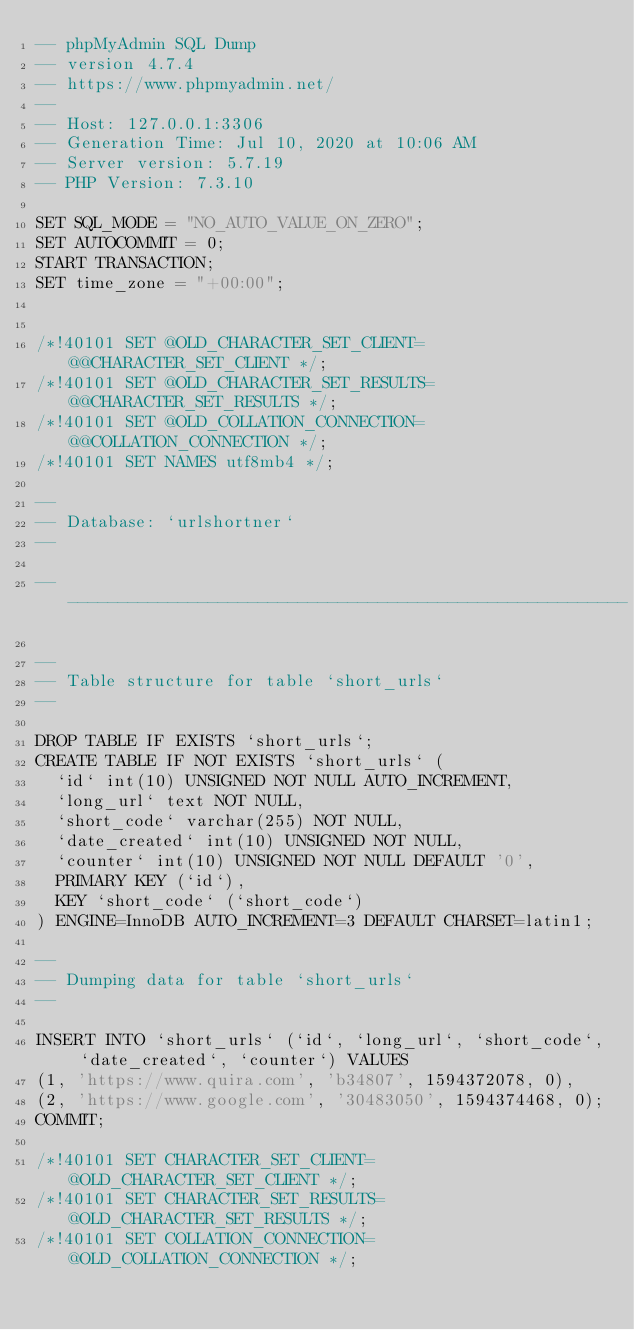<code> <loc_0><loc_0><loc_500><loc_500><_SQL_>-- phpMyAdmin SQL Dump
-- version 4.7.4
-- https://www.phpmyadmin.net/
--
-- Host: 127.0.0.1:3306
-- Generation Time: Jul 10, 2020 at 10:06 AM
-- Server version: 5.7.19
-- PHP Version: 7.3.10

SET SQL_MODE = "NO_AUTO_VALUE_ON_ZERO";
SET AUTOCOMMIT = 0;
START TRANSACTION;
SET time_zone = "+00:00";


/*!40101 SET @OLD_CHARACTER_SET_CLIENT=@@CHARACTER_SET_CLIENT */;
/*!40101 SET @OLD_CHARACTER_SET_RESULTS=@@CHARACTER_SET_RESULTS */;
/*!40101 SET @OLD_COLLATION_CONNECTION=@@COLLATION_CONNECTION */;
/*!40101 SET NAMES utf8mb4 */;

--
-- Database: `urlshortner`
--

-- --------------------------------------------------------

--
-- Table structure for table `short_urls`
--

DROP TABLE IF EXISTS `short_urls`;
CREATE TABLE IF NOT EXISTS `short_urls` (
  `id` int(10) UNSIGNED NOT NULL AUTO_INCREMENT,
  `long_url` text NOT NULL,
  `short_code` varchar(255) NOT NULL,
  `date_created` int(10) UNSIGNED NOT NULL,
  `counter` int(10) UNSIGNED NOT NULL DEFAULT '0',
  PRIMARY KEY (`id`),
  KEY `short_code` (`short_code`)
) ENGINE=InnoDB AUTO_INCREMENT=3 DEFAULT CHARSET=latin1;

--
-- Dumping data for table `short_urls`
--

INSERT INTO `short_urls` (`id`, `long_url`, `short_code`, `date_created`, `counter`) VALUES
(1, 'https://www.quira.com', 'b34807', 1594372078, 0),
(2, 'https://www.google.com', '30483050', 1594374468, 0);
COMMIT;

/*!40101 SET CHARACTER_SET_CLIENT=@OLD_CHARACTER_SET_CLIENT */;
/*!40101 SET CHARACTER_SET_RESULTS=@OLD_CHARACTER_SET_RESULTS */;
/*!40101 SET COLLATION_CONNECTION=@OLD_COLLATION_CONNECTION */;
</code> 